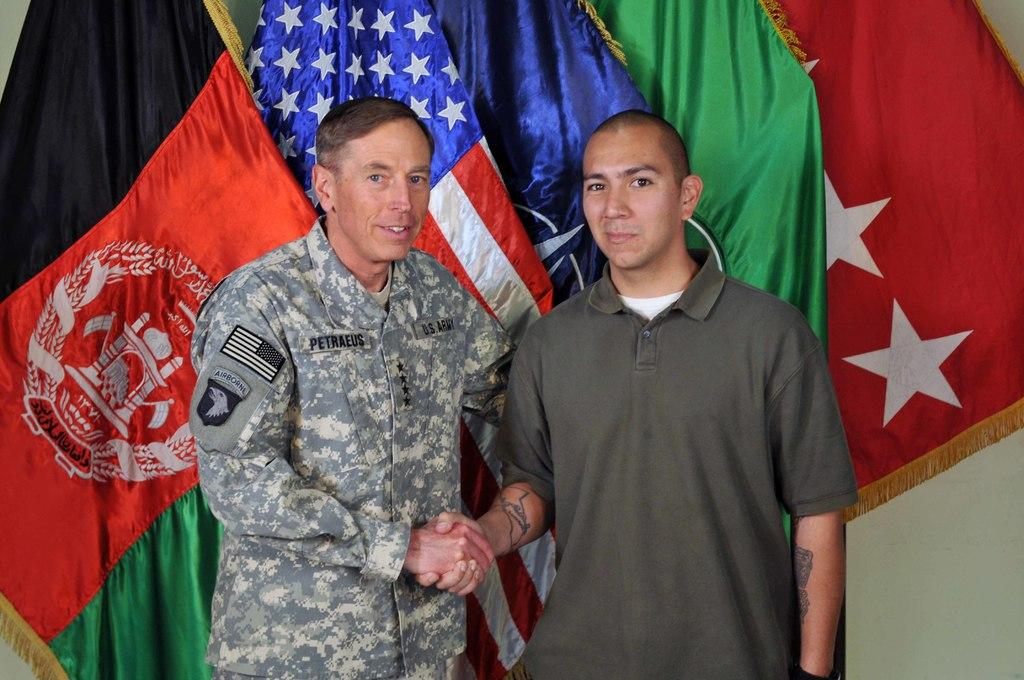<image>
Share a concise interpretation of the image provided. An army man by the name of PETRAEUS shaking hands with another. 